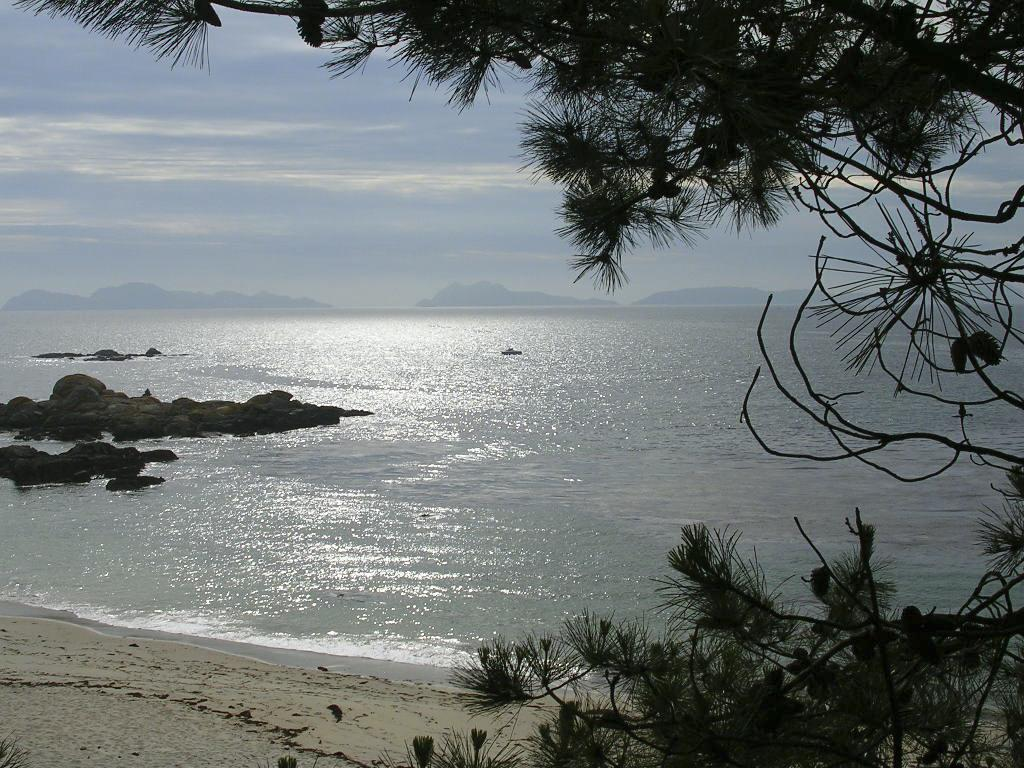What type of natural environment is depicted in the image? There is a sea in the image. What type of vegetation can be seen on the right side of the image? There are trees on the right side of the image. What is visible at the top of the image? The sky is visible at the top of the image. How many tickets are visible in the image? There are no tickets present in the image. What type of channel can be seen in the image? There is no channel present in the image; it features a sea, trees, and the sky. 